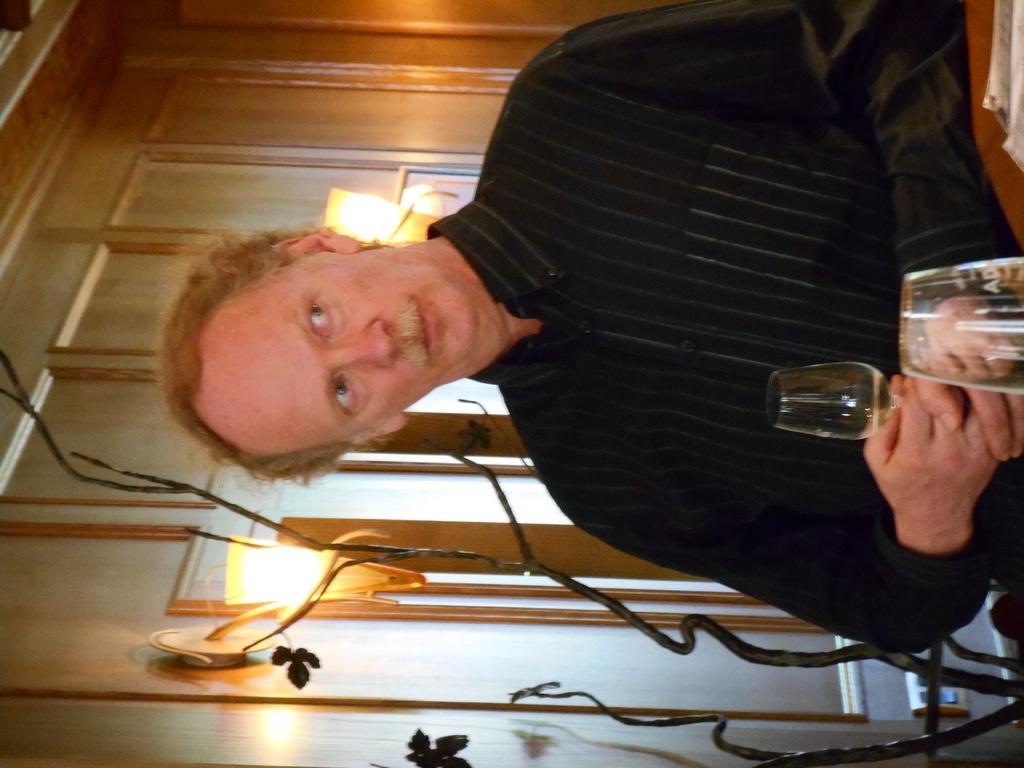How would you summarize this image in a sentence or two? This man wore black shirt and staring. This man is holding a glass. On wall there are lights. 